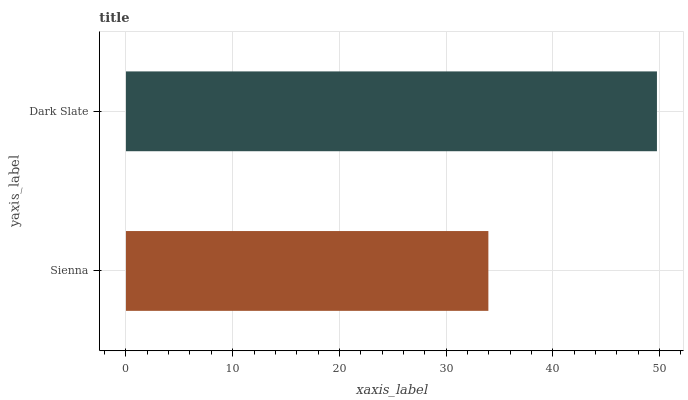Is Sienna the minimum?
Answer yes or no. Yes. Is Dark Slate the maximum?
Answer yes or no. Yes. Is Dark Slate the minimum?
Answer yes or no. No. Is Dark Slate greater than Sienna?
Answer yes or no. Yes. Is Sienna less than Dark Slate?
Answer yes or no. Yes. Is Sienna greater than Dark Slate?
Answer yes or no. No. Is Dark Slate less than Sienna?
Answer yes or no. No. Is Dark Slate the high median?
Answer yes or no. Yes. Is Sienna the low median?
Answer yes or no. Yes. Is Sienna the high median?
Answer yes or no. No. Is Dark Slate the low median?
Answer yes or no. No. 